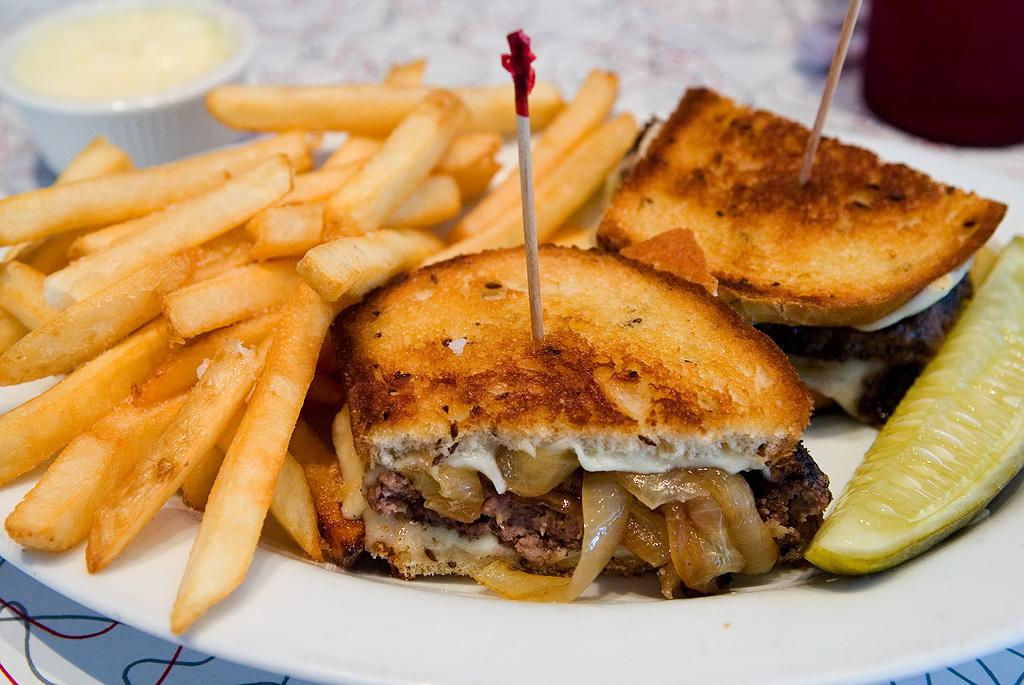What is the color of the plate in the image? The plate in the image is white. What is on the plate? The plate has some eatables on it, including french fries and burgers. Where is the bowl located in the image? The bowl is in the top left corner of the image. What type of creature can be seen holding a club in the image? There is no creature or club present in the image. What kind of vessel is used for serving the food in the image? The image does not show a vessel used for serving the food; it only shows a plate and a bowl. 